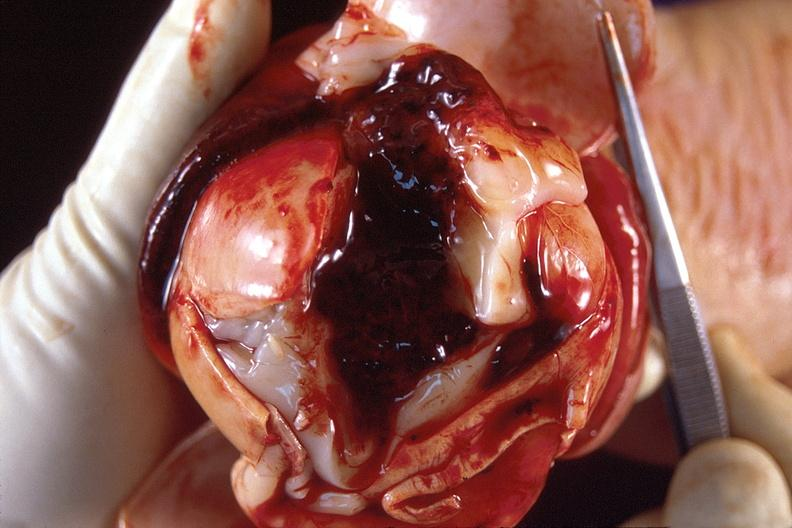s nervous present?
Answer the question using a single word or phrase. Yes 